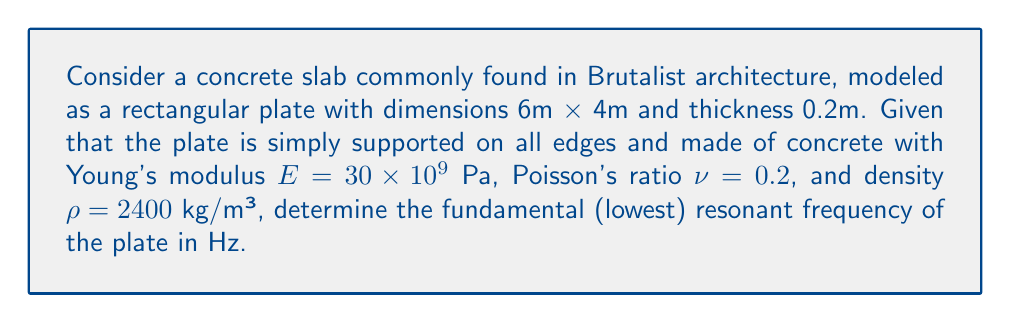Provide a solution to this math problem. To find the fundamental resonant frequency of the rectangular plate, we'll follow these steps:

1) The formula for the natural frequencies of a simply supported rectangular plate is:

   $$f_{mn} = \frac{\pi}{2} \sqrt{\frac{D}{\rho h}} \sqrt{\left(\frac{m}{a}\right)^2 + \left(\frac{n}{b}\right)^2}$$

   where $m$ and $n$ are mode numbers, $a$ and $b$ are the plate dimensions, $h$ is the thickness, $\rho$ is the density, and $D$ is the flexural rigidity.

2) Calculate the flexural rigidity $D$:

   $$D = \frac{E h^3}{12(1-\nu^2)}$$
   $$D = \frac{30 \times 10^9 \times 0.2^3}{12(1-0.2^2)} = 20,833,333 \text{ N⋅m}$$

3) For the fundamental frequency, $m=1$ and $n=1$. Substituting all values:

   $$f_{11} = \frac{\pi}{2} \sqrt{\frac{20,833,333}{2400 \times 0.2}} \sqrt{\left(\frac{1}{6}\right)^2 + \left(\frac{1}{4}\right)^2}$$

4) Simplify and calculate:

   $$f_{11} = \frac{\pi}{2} \sqrt{\frac{20,833,333}{480}} \sqrt{0.0278 + 0.0625}$$
   $$f_{11} = 1.57 \times 208.33 \times 0.3062 = 99.96 \text{ Hz}$$

5) Round to two decimal places:

   $$f_{11} \approx 99.96 \text{ Hz}$$
Answer: 99.96 Hz 